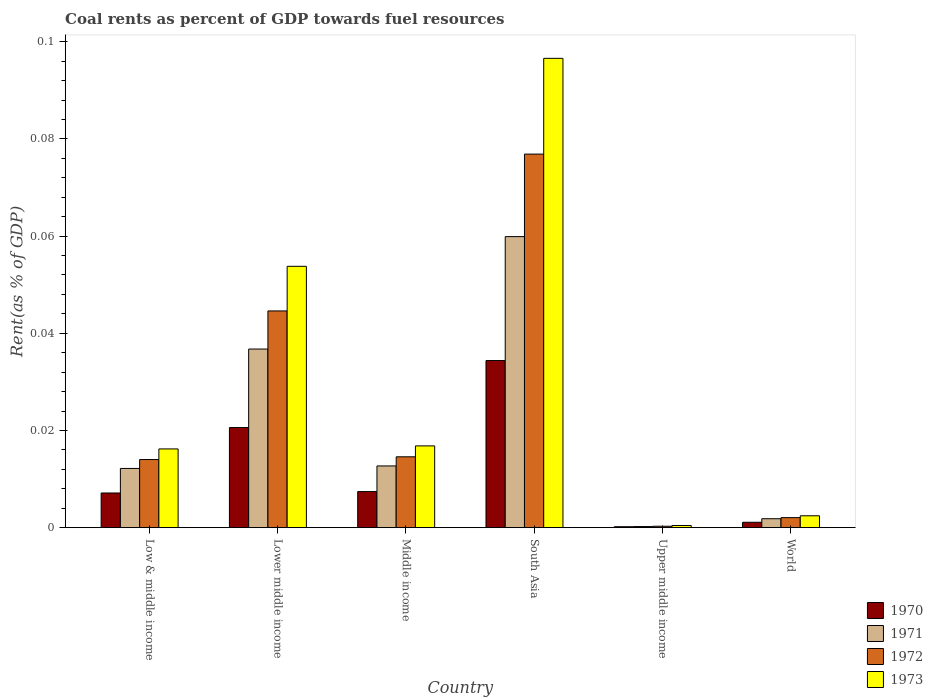How many different coloured bars are there?
Offer a very short reply. 4. How many groups of bars are there?
Provide a short and direct response. 6. How many bars are there on the 2nd tick from the left?
Your answer should be compact. 4. What is the label of the 2nd group of bars from the left?
Give a very brief answer. Lower middle income. In how many cases, is the number of bars for a given country not equal to the number of legend labels?
Provide a succinct answer. 0. What is the coal rent in 1970 in Lower middle income?
Ensure brevity in your answer.  0.02. Across all countries, what is the maximum coal rent in 1973?
Keep it short and to the point. 0.1. Across all countries, what is the minimum coal rent in 1970?
Provide a succinct answer. 0. In which country was the coal rent in 1971 minimum?
Provide a short and direct response. Upper middle income. What is the total coal rent in 1973 in the graph?
Offer a terse response. 0.19. What is the difference between the coal rent in 1971 in South Asia and that in World?
Your answer should be very brief. 0.06. What is the difference between the coal rent in 1972 in Middle income and the coal rent in 1973 in Lower middle income?
Your response must be concise. -0.04. What is the average coal rent in 1971 per country?
Your answer should be compact. 0.02. What is the difference between the coal rent of/in 1970 and coal rent of/in 1973 in Low & middle income?
Your response must be concise. -0.01. In how many countries, is the coal rent in 1970 greater than 0.04 %?
Keep it short and to the point. 0. What is the ratio of the coal rent in 1973 in Lower middle income to that in World?
Your answer should be compact. 22.07. Is the coal rent in 1973 in Middle income less than that in Upper middle income?
Offer a terse response. No. What is the difference between the highest and the second highest coal rent in 1972?
Give a very brief answer. 0.03. What is the difference between the highest and the lowest coal rent in 1972?
Ensure brevity in your answer.  0.08. In how many countries, is the coal rent in 1970 greater than the average coal rent in 1970 taken over all countries?
Give a very brief answer. 2. What does the 3rd bar from the left in Middle income represents?
Ensure brevity in your answer.  1972. What does the 3rd bar from the right in Lower middle income represents?
Make the answer very short. 1971. Is it the case that in every country, the sum of the coal rent in 1970 and coal rent in 1972 is greater than the coal rent in 1971?
Your response must be concise. Yes. Are all the bars in the graph horizontal?
Your answer should be very brief. No. How many countries are there in the graph?
Provide a succinct answer. 6. Are the values on the major ticks of Y-axis written in scientific E-notation?
Offer a terse response. No. Does the graph contain any zero values?
Provide a succinct answer. No. Does the graph contain grids?
Give a very brief answer. No. Where does the legend appear in the graph?
Provide a succinct answer. Bottom right. How are the legend labels stacked?
Give a very brief answer. Vertical. What is the title of the graph?
Make the answer very short. Coal rents as percent of GDP towards fuel resources. What is the label or title of the Y-axis?
Make the answer very short. Rent(as % of GDP). What is the Rent(as % of GDP) of 1970 in Low & middle income?
Give a very brief answer. 0.01. What is the Rent(as % of GDP) of 1971 in Low & middle income?
Give a very brief answer. 0.01. What is the Rent(as % of GDP) of 1972 in Low & middle income?
Your answer should be very brief. 0.01. What is the Rent(as % of GDP) in 1973 in Low & middle income?
Give a very brief answer. 0.02. What is the Rent(as % of GDP) in 1970 in Lower middle income?
Offer a terse response. 0.02. What is the Rent(as % of GDP) in 1971 in Lower middle income?
Your answer should be compact. 0.04. What is the Rent(as % of GDP) of 1972 in Lower middle income?
Your answer should be very brief. 0.04. What is the Rent(as % of GDP) in 1973 in Lower middle income?
Provide a succinct answer. 0.05. What is the Rent(as % of GDP) in 1970 in Middle income?
Keep it short and to the point. 0.01. What is the Rent(as % of GDP) of 1971 in Middle income?
Offer a very short reply. 0.01. What is the Rent(as % of GDP) in 1972 in Middle income?
Offer a very short reply. 0.01. What is the Rent(as % of GDP) of 1973 in Middle income?
Your answer should be compact. 0.02. What is the Rent(as % of GDP) in 1970 in South Asia?
Give a very brief answer. 0.03. What is the Rent(as % of GDP) in 1971 in South Asia?
Offer a terse response. 0.06. What is the Rent(as % of GDP) in 1972 in South Asia?
Offer a terse response. 0.08. What is the Rent(as % of GDP) of 1973 in South Asia?
Your response must be concise. 0.1. What is the Rent(as % of GDP) of 1970 in Upper middle income?
Offer a terse response. 0. What is the Rent(as % of GDP) in 1971 in Upper middle income?
Keep it short and to the point. 0. What is the Rent(as % of GDP) of 1972 in Upper middle income?
Make the answer very short. 0. What is the Rent(as % of GDP) of 1973 in Upper middle income?
Your answer should be very brief. 0. What is the Rent(as % of GDP) of 1970 in World?
Your response must be concise. 0. What is the Rent(as % of GDP) in 1971 in World?
Your response must be concise. 0. What is the Rent(as % of GDP) in 1972 in World?
Your answer should be very brief. 0. What is the Rent(as % of GDP) of 1973 in World?
Your answer should be compact. 0. Across all countries, what is the maximum Rent(as % of GDP) of 1970?
Your answer should be very brief. 0.03. Across all countries, what is the maximum Rent(as % of GDP) of 1971?
Provide a succinct answer. 0.06. Across all countries, what is the maximum Rent(as % of GDP) in 1972?
Give a very brief answer. 0.08. Across all countries, what is the maximum Rent(as % of GDP) of 1973?
Your answer should be compact. 0.1. Across all countries, what is the minimum Rent(as % of GDP) in 1970?
Your answer should be very brief. 0. Across all countries, what is the minimum Rent(as % of GDP) of 1971?
Ensure brevity in your answer.  0. Across all countries, what is the minimum Rent(as % of GDP) of 1972?
Give a very brief answer. 0. Across all countries, what is the minimum Rent(as % of GDP) of 1973?
Provide a short and direct response. 0. What is the total Rent(as % of GDP) of 1970 in the graph?
Offer a terse response. 0.07. What is the total Rent(as % of GDP) of 1971 in the graph?
Ensure brevity in your answer.  0.12. What is the total Rent(as % of GDP) of 1972 in the graph?
Your answer should be compact. 0.15. What is the total Rent(as % of GDP) of 1973 in the graph?
Offer a very short reply. 0.19. What is the difference between the Rent(as % of GDP) of 1970 in Low & middle income and that in Lower middle income?
Your answer should be very brief. -0.01. What is the difference between the Rent(as % of GDP) in 1971 in Low & middle income and that in Lower middle income?
Make the answer very short. -0.02. What is the difference between the Rent(as % of GDP) in 1972 in Low & middle income and that in Lower middle income?
Provide a succinct answer. -0.03. What is the difference between the Rent(as % of GDP) in 1973 in Low & middle income and that in Lower middle income?
Offer a terse response. -0.04. What is the difference between the Rent(as % of GDP) of 1970 in Low & middle income and that in Middle income?
Provide a succinct answer. -0. What is the difference between the Rent(as % of GDP) of 1971 in Low & middle income and that in Middle income?
Make the answer very short. -0. What is the difference between the Rent(as % of GDP) of 1972 in Low & middle income and that in Middle income?
Your answer should be very brief. -0. What is the difference between the Rent(as % of GDP) of 1973 in Low & middle income and that in Middle income?
Offer a very short reply. -0. What is the difference between the Rent(as % of GDP) of 1970 in Low & middle income and that in South Asia?
Offer a terse response. -0.03. What is the difference between the Rent(as % of GDP) in 1971 in Low & middle income and that in South Asia?
Offer a very short reply. -0.05. What is the difference between the Rent(as % of GDP) in 1972 in Low & middle income and that in South Asia?
Offer a very short reply. -0.06. What is the difference between the Rent(as % of GDP) of 1973 in Low & middle income and that in South Asia?
Ensure brevity in your answer.  -0.08. What is the difference between the Rent(as % of GDP) in 1970 in Low & middle income and that in Upper middle income?
Provide a succinct answer. 0.01. What is the difference between the Rent(as % of GDP) in 1971 in Low & middle income and that in Upper middle income?
Ensure brevity in your answer.  0.01. What is the difference between the Rent(as % of GDP) of 1972 in Low & middle income and that in Upper middle income?
Keep it short and to the point. 0.01. What is the difference between the Rent(as % of GDP) of 1973 in Low & middle income and that in Upper middle income?
Offer a very short reply. 0.02. What is the difference between the Rent(as % of GDP) in 1970 in Low & middle income and that in World?
Ensure brevity in your answer.  0.01. What is the difference between the Rent(as % of GDP) of 1971 in Low & middle income and that in World?
Give a very brief answer. 0.01. What is the difference between the Rent(as % of GDP) in 1972 in Low & middle income and that in World?
Keep it short and to the point. 0.01. What is the difference between the Rent(as % of GDP) in 1973 in Low & middle income and that in World?
Provide a short and direct response. 0.01. What is the difference between the Rent(as % of GDP) of 1970 in Lower middle income and that in Middle income?
Make the answer very short. 0.01. What is the difference between the Rent(as % of GDP) of 1971 in Lower middle income and that in Middle income?
Offer a very short reply. 0.02. What is the difference between the Rent(as % of GDP) of 1972 in Lower middle income and that in Middle income?
Keep it short and to the point. 0.03. What is the difference between the Rent(as % of GDP) in 1973 in Lower middle income and that in Middle income?
Keep it short and to the point. 0.04. What is the difference between the Rent(as % of GDP) in 1970 in Lower middle income and that in South Asia?
Make the answer very short. -0.01. What is the difference between the Rent(as % of GDP) of 1971 in Lower middle income and that in South Asia?
Provide a succinct answer. -0.02. What is the difference between the Rent(as % of GDP) of 1972 in Lower middle income and that in South Asia?
Provide a short and direct response. -0.03. What is the difference between the Rent(as % of GDP) of 1973 in Lower middle income and that in South Asia?
Give a very brief answer. -0.04. What is the difference between the Rent(as % of GDP) in 1970 in Lower middle income and that in Upper middle income?
Make the answer very short. 0.02. What is the difference between the Rent(as % of GDP) in 1971 in Lower middle income and that in Upper middle income?
Provide a succinct answer. 0.04. What is the difference between the Rent(as % of GDP) of 1972 in Lower middle income and that in Upper middle income?
Provide a succinct answer. 0.04. What is the difference between the Rent(as % of GDP) in 1973 in Lower middle income and that in Upper middle income?
Keep it short and to the point. 0.05. What is the difference between the Rent(as % of GDP) in 1970 in Lower middle income and that in World?
Your answer should be compact. 0.02. What is the difference between the Rent(as % of GDP) of 1971 in Lower middle income and that in World?
Your answer should be compact. 0.03. What is the difference between the Rent(as % of GDP) in 1972 in Lower middle income and that in World?
Provide a succinct answer. 0.04. What is the difference between the Rent(as % of GDP) in 1973 in Lower middle income and that in World?
Provide a succinct answer. 0.05. What is the difference between the Rent(as % of GDP) of 1970 in Middle income and that in South Asia?
Offer a very short reply. -0.03. What is the difference between the Rent(as % of GDP) of 1971 in Middle income and that in South Asia?
Your response must be concise. -0.05. What is the difference between the Rent(as % of GDP) of 1972 in Middle income and that in South Asia?
Your answer should be compact. -0.06. What is the difference between the Rent(as % of GDP) of 1973 in Middle income and that in South Asia?
Give a very brief answer. -0.08. What is the difference between the Rent(as % of GDP) in 1970 in Middle income and that in Upper middle income?
Provide a succinct answer. 0.01. What is the difference between the Rent(as % of GDP) in 1971 in Middle income and that in Upper middle income?
Provide a succinct answer. 0.01. What is the difference between the Rent(as % of GDP) in 1972 in Middle income and that in Upper middle income?
Your response must be concise. 0.01. What is the difference between the Rent(as % of GDP) of 1973 in Middle income and that in Upper middle income?
Your response must be concise. 0.02. What is the difference between the Rent(as % of GDP) of 1970 in Middle income and that in World?
Your answer should be very brief. 0.01. What is the difference between the Rent(as % of GDP) of 1971 in Middle income and that in World?
Provide a short and direct response. 0.01. What is the difference between the Rent(as % of GDP) of 1972 in Middle income and that in World?
Your answer should be compact. 0.01. What is the difference between the Rent(as % of GDP) of 1973 in Middle income and that in World?
Make the answer very short. 0.01. What is the difference between the Rent(as % of GDP) in 1970 in South Asia and that in Upper middle income?
Keep it short and to the point. 0.03. What is the difference between the Rent(as % of GDP) in 1971 in South Asia and that in Upper middle income?
Your response must be concise. 0.06. What is the difference between the Rent(as % of GDP) in 1972 in South Asia and that in Upper middle income?
Offer a very short reply. 0.08. What is the difference between the Rent(as % of GDP) of 1973 in South Asia and that in Upper middle income?
Offer a very short reply. 0.1. What is the difference between the Rent(as % of GDP) of 1970 in South Asia and that in World?
Ensure brevity in your answer.  0.03. What is the difference between the Rent(as % of GDP) of 1971 in South Asia and that in World?
Make the answer very short. 0.06. What is the difference between the Rent(as % of GDP) in 1972 in South Asia and that in World?
Provide a succinct answer. 0.07. What is the difference between the Rent(as % of GDP) in 1973 in South Asia and that in World?
Offer a terse response. 0.09. What is the difference between the Rent(as % of GDP) in 1970 in Upper middle income and that in World?
Your response must be concise. -0. What is the difference between the Rent(as % of GDP) of 1971 in Upper middle income and that in World?
Make the answer very short. -0. What is the difference between the Rent(as % of GDP) in 1972 in Upper middle income and that in World?
Your answer should be very brief. -0. What is the difference between the Rent(as % of GDP) of 1973 in Upper middle income and that in World?
Your answer should be compact. -0. What is the difference between the Rent(as % of GDP) in 1970 in Low & middle income and the Rent(as % of GDP) in 1971 in Lower middle income?
Provide a short and direct response. -0.03. What is the difference between the Rent(as % of GDP) of 1970 in Low & middle income and the Rent(as % of GDP) of 1972 in Lower middle income?
Your response must be concise. -0.04. What is the difference between the Rent(as % of GDP) in 1970 in Low & middle income and the Rent(as % of GDP) in 1973 in Lower middle income?
Provide a short and direct response. -0.05. What is the difference between the Rent(as % of GDP) in 1971 in Low & middle income and the Rent(as % of GDP) in 1972 in Lower middle income?
Provide a short and direct response. -0.03. What is the difference between the Rent(as % of GDP) of 1971 in Low & middle income and the Rent(as % of GDP) of 1973 in Lower middle income?
Your answer should be very brief. -0.04. What is the difference between the Rent(as % of GDP) in 1972 in Low & middle income and the Rent(as % of GDP) in 1973 in Lower middle income?
Offer a very short reply. -0.04. What is the difference between the Rent(as % of GDP) in 1970 in Low & middle income and the Rent(as % of GDP) in 1971 in Middle income?
Provide a succinct answer. -0.01. What is the difference between the Rent(as % of GDP) of 1970 in Low & middle income and the Rent(as % of GDP) of 1972 in Middle income?
Give a very brief answer. -0.01. What is the difference between the Rent(as % of GDP) of 1970 in Low & middle income and the Rent(as % of GDP) of 1973 in Middle income?
Offer a very short reply. -0.01. What is the difference between the Rent(as % of GDP) of 1971 in Low & middle income and the Rent(as % of GDP) of 1972 in Middle income?
Provide a succinct answer. -0. What is the difference between the Rent(as % of GDP) in 1971 in Low & middle income and the Rent(as % of GDP) in 1973 in Middle income?
Your answer should be very brief. -0. What is the difference between the Rent(as % of GDP) of 1972 in Low & middle income and the Rent(as % of GDP) of 1973 in Middle income?
Ensure brevity in your answer.  -0. What is the difference between the Rent(as % of GDP) in 1970 in Low & middle income and the Rent(as % of GDP) in 1971 in South Asia?
Give a very brief answer. -0.05. What is the difference between the Rent(as % of GDP) of 1970 in Low & middle income and the Rent(as % of GDP) of 1972 in South Asia?
Ensure brevity in your answer.  -0.07. What is the difference between the Rent(as % of GDP) in 1970 in Low & middle income and the Rent(as % of GDP) in 1973 in South Asia?
Keep it short and to the point. -0.09. What is the difference between the Rent(as % of GDP) in 1971 in Low & middle income and the Rent(as % of GDP) in 1972 in South Asia?
Your response must be concise. -0.06. What is the difference between the Rent(as % of GDP) in 1971 in Low & middle income and the Rent(as % of GDP) in 1973 in South Asia?
Give a very brief answer. -0.08. What is the difference between the Rent(as % of GDP) of 1972 in Low & middle income and the Rent(as % of GDP) of 1973 in South Asia?
Give a very brief answer. -0.08. What is the difference between the Rent(as % of GDP) in 1970 in Low & middle income and the Rent(as % of GDP) in 1971 in Upper middle income?
Give a very brief answer. 0.01. What is the difference between the Rent(as % of GDP) in 1970 in Low & middle income and the Rent(as % of GDP) in 1972 in Upper middle income?
Provide a short and direct response. 0.01. What is the difference between the Rent(as % of GDP) of 1970 in Low & middle income and the Rent(as % of GDP) of 1973 in Upper middle income?
Offer a very short reply. 0.01. What is the difference between the Rent(as % of GDP) in 1971 in Low & middle income and the Rent(as % of GDP) in 1972 in Upper middle income?
Your response must be concise. 0.01. What is the difference between the Rent(as % of GDP) of 1971 in Low & middle income and the Rent(as % of GDP) of 1973 in Upper middle income?
Offer a terse response. 0.01. What is the difference between the Rent(as % of GDP) in 1972 in Low & middle income and the Rent(as % of GDP) in 1973 in Upper middle income?
Provide a succinct answer. 0.01. What is the difference between the Rent(as % of GDP) in 1970 in Low & middle income and the Rent(as % of GDP) in 1971 in World?
Ensure brevity in your answer.  0.01. What is the difference between the Rent(as % of GDP) in 1970 in Low & middle income and the Rent(as % of GDP) in 1972 in World?
Keep it short and to the point. 0.01. What is the difference between the Rent(as % of GDP) of 1970 in Low & middle income and the Rent(as % of GDP) of 1973 in World?
Give a very brief answer. 0. What is the difference between the Rent(as % of GDP) of 1971 in Low & middle income and the Rent(as % of GDP) of 1972 in World?
Provide a succinct answer. 0.01. What is the difference between the Rent(as % of GDP) in 1971 in Low & middle income and the Rent(as % of GDP) in 1973 in World?
Your answer should be very brief. 0.01. What is the difference between the Rent(as % of GDP) in 1972 in Low & middle income and the Rent(as % of GDP) in 1973 in World?
Offer a terse response. 0.01. What is the difference between the Rent(as % of GDP) in 1970 in Lower middle income and the Rent(as % of GDP) in 1971 in Middle income?
Give a very brief answer. 0.01. What is the difference between the Rent(as % of GDP) of 1970 in Lower middle income and the Rent(as % of GDP) of 1972 in Middle income?
Your answer should be compact. 0.01. What is the difference between the Rent(as % of GDP) in 1970 in Lower middle income and the Rent(as % of GDP) in 1973 in Middle income?
Provide a succinct answer. 0. What is the difference between the Rent(as % of GDP) in 1971 in Lower middle income and the Rent(as % of GDP) in 1972 in Middle income?
Provide a succinct answer. 0.02. What is the difference between the Rent(as % of GDP) in 1971 in Lower middle income and the Rent(as % of GDP) in 1973 in Middle income?
Your answer should be very brief. 0.02. What is the difference between the Rent(as % of GDP) in 1972 in Lower middle income and the Rent(as % of GDP) in 1973 in Middle income?
Keep it short and to the point. 0.03. What is the difference between the Rent(as % of GDP) of 1970 in Lower middle income and the Rent(as % of GDP) of 1971 in South Asia?
Offer a terse response. -0.04. What is the difference between the Rent(as % of GDP) of 1970 in Lower middle income and the Rent(as % of GDP) of 1972 in South Asia?
Make the answer very short. -0.06. What is the difference between the Rent(as % of GDP) of 1970 in Lower middle income and the Rent(as % of GDP) of 1973 in South Asia?
Give a very brief answer. -0.08. What is the difference between the Rent(as % of GDP) of 1971 in Lower middle income and the Rent(as % of GDP) of 1972 in South Asia?
Provide a short and direct response. -0.04. What is the difference between the Rent(as % of GDP) of 1971 in Lower middle income and the Rent(as % of GDP) of 1973 in South Asia?
Offer a very short reply. -0.06. What is the difference between the Rent(as % of GDP) of 1972 in Lower middle income and the Rent(as % of GDP) of 1973 in South Asia?
Keep it short and to the point. -0.05. What is the difference between the Rent(as % of GDP) in 1970 in Lower middle income and the Rent(as % of GDP) in 1971 in Upper middle income?
Offer a terse response. 0.02. What is the difference between the Rent(as % of GDP) of 1970 in Lower middle income and the Rent(as % of GDP) of 1972 in Upper middle income?
Ensure brevity in your answer.  0.02. What is the difference between the Rent(as % of GDP) of 1970 in Lower middle income and the Rent(as % of GDP) of 1973 in Upper middle income?
Your answer should be compact. 0.02. What is the difference between the Rent(as % of GDP) in 1971 in Lower middle income and the Rent(as % of GDP) in 1972 in Upper middle income?
Make the answer very short. 0.04. What is the difference between the Rent(as % of GDP) in 1971 in Lower middle income and the Rent(as % of GDP) in 1973 in Upper middle income?
Give a very brief answer. 0.04. What is the difference between the Rent(as % of GDP) in 1972 in Lower middle income and the Rent(as % of GDP) in 1973 in Upper middle income?
Your response must be concise. 0.04. What is the difference between the Rent(as % of GDP) of 1970 in Lower middle income and the Rent(as % of GDP) of 1971 in World?
Your answer should be very brief. 0.02. What is the difference between the Rent(as % of GDP) of 1970 in Lower middle income and the Rent(as % of GDP) of 1972 in World?
Your response must be concise. 0.02. What is the difference between the Rent(as % of GDP) of 1970 in Lower middle income and the Rent(as % of GDP) of 1973 in World?
Offer a very short reply. 0.02. What is the difference between the Rent(as % of GDP) of 1971 in Lower middle income and the Rent(as % of GDP) of 1972 in World?
Offer a terse response. 0.03. What is the difference between the Rent(as % of GDP) of 1971 in Lower middle income and the Rent(as % of GDP) of 1973 in World?
Ensure brevity in your answer.  0.03. What is the difference between the Rent(as % of GDP) of 1972 in Lower middle income and the Rent(as % of GDP) of 1973 in World?
Give a very brief answer. 0.04. What is the difference between the Rent(as % of GDP) of 1970 in Middle income and the Rent(as % of GDP) of 1971 in South Asia?
Your answer should be compact. -0.05. What is the difference between the Rent(as % of GDP) of 1970 in Middle income and the Rent(as % of GDP) of 1972 in South Asia?
Offer a very short reply. -0.07. What is the difference between the Rent(as % of GDP) of 1970 in Middle income and the Rent(as % of GDP) of 1973 in South Asia?
Offer a very short reply. -0.09. What is the difference between the Rent(as % of GDP) of 1971 in Middle income and the Rent(as % of GDP) of 1972 in South Asia?
Your response must be concise. -0.06. What is the difference between the Rent(as % of GDP) of 1971 in Middle income and the Rent(as % of GDP) of 1973 in South Asia?
Offer a terse response. -0.08. What is the difference between the Rent(as % of GDP) of 1972 in Middle income and the Rent(as % of GDP) of 1973 in South Asia?
Provide a short and direct response. -0.08. What is the difference between the Rent(as % of GDP) of 1970 in Middle income and the Rent(as % of GDP) of 1971 in Upper middle income?
Offer a terse response. 0.01. What is the difference between the Rent(as % of GDP) of 1970 in Middle income and the Rent(as % of GDP) of 1972 in Upper middle income?
Provide a succinct answer. 0.01. What is the difference between the Rent(as % of GDP) of 1970 in Middle income and the Rent(as % of GDP) of 1973 in Upper middle income?
Offer a very short reply. 0.01. What is the difference between the Rent(as % of GDP) of 1971 in Middle income and the Rent(as % of GDP) of 1972 in Upper middle income?
Provide a succinct answer. 0.01. What is the difference between the Rent(as % of GDP) in 1971 in Middle income and the Rent(as % of GDP) in 1973 in Upper middle income?
Provide a short and direct response. 0.01. What is the difference between the Rent(as % of GDP) of 1972 in Middle income and the Rent(as % of GDP) of 1973 in Upper middle income?
Keep it short and to the point. 0.01. What is the difference between the Rent(as % of GDP) in 1970 in Middle income and the Rent(as % of GDP) in 1971 in World?
Provide a succinct answer. 0.01. What is the difference between the Rent(as % of GDP) in 1970 in Middle income and the Rent(as % of GDP) in 1972 in World?
Your answer should be compact. 0.01. What is the difference between the Rent(as % of GDP) in 1970 in Middle income and the Rent(as % of GDP) in 1973 in World?
Offer a very short reply. 0.01. What is the difference between the Rent(as % of GDP) of 1971 in Middle income and the Rent(as % of GDP) of 1972 in World?
Offer a very short reply. 0.01. What is the difference between the Rent(as % of GDP) in 1971 in Middle income and the Rent(as % of GDP) in 1973 in World?
Make the answer very short. 0.01. What is the difference between the Rent(as % of GDP) in 1972 in Middle income and the Rent(as % of GDP) in 1973 in World?
Keep it short and to the point. 0.01. What is the difference between the Rent(as % of GDP) of 1970 in South Asia and the Rent(as % of GDP) of 1971 in Upper middle income?
Ensure brevity in your answer.  0.03. What is the difference between the Rent(as % of GDP) of 1970 in South Asia and the Rent(as % of GDP) of 1972 in Upper middle income?
Give a very brief answer. 0.03. What is the difference between the Rent(as % of GDP) in 1970 in South Asia and the Rent(as % of GDP) in 1973 in Upper middle income?
Provide a succinct answer. 0.03. What is the difference between the Rent(as % of GDP) in 1971 in South Asia and the Rent(as % of GDP) in 1972 in Upper middle income?
Keep it short and to the point. 0.06. What is the difference between the Rent(as % of GDP) in 1971 in South Asia and the Rent(as % of GDP) in 1973 in Upper middle income?
Offer a very short reply. 0.06. What is the difference between the Rent(as % of GDP) in 1972 in South Asia and the Rent(as % of GDP) in 1973 in Upper middle income?
Your response must be concise. 0.08. What is the difference between the Rent(as % of GDP) in 1970 in South Asia and the Rent(as % of GDP) in 1971 in World?
Your answer should be compact. 0.03. What is the difference between the Rent(as % of GDP) in 1970 in South Asia and the Rent(as % of GDP) in 1972 in World?
Your answer should be compact. 0.03. What is the difference between the Rent(as % of GDP) in 1970 in South Asia and the Rent(as % of GDP) in 1973 in World?
Give a very brief answer. 0.03. What is the difference between the Rent(as % of GDP) of 1971 in South Asia and the Rent(as % of GDP) of 1972 in World?
Keep it short and to the point. 0.06. What is the difference between the Rent(as % of GDP) of 1971 in South Asia and the Rent(as % of GDP) of 1973 in World?
Keep it short and to the point. 0.06. What is the difference between the Rent(as % of GDP) of 1972 in South Asia and the Rent(as % of GDP) of 1973 in World?
Ensure brevity in your answer.  0.07. What is the difference between the Rent(as % of GDP) in 1970 in Upper middle income and the Rent(as % of GDP) in 1971 in World?
Keep it short and to the point. -0. What is the difference between the Rent(as % of GDP) of 1970 in Upper middle income and the Rent(as % of GDP) of 1972 in World?
Your answer should be very brief. -0. What is the difference between the Rent(as % of GDP) of 1970 in Upper middle income and the Rent(as % of GDP) of 1973 in World?
Offer a very short reply. -0. What is the difference between the Rent(as % of GDP) of 1971 in Upper middle income and the Rent(as % of GDP) of 1972 in World?
Keep it short and to the point. -0. What is the difference between the Rent(as % of GDP) of 1971 in Upper middle income and the Rent(as % of GDP) of 1973 in World?
Your answer should be compact. -0. What is the difference between the Rent(as % of GDP) of 1972 in Upper middle income and the Rent(as % of GDP) of 1973 in World?
Make the answer very short. -0. What is the average Rent(as % of GDP) of 1970 per country?
Provide a short and direct response. 0.01. What is the average Rent(as % of GDP) in 1971 per country?
Your answer should be compact. 0.02. What is the average Rent(as % of GDP) of 1972 per country?
Your answer should be very brief. 0.03. What is the average Rent(as % of GDP) in 1973 per country?
Offer a very short reply. 0.03. What is the difference between the Rent(as % of GDP) of 1970 and Rent(as % of GDP) of 1971 in Low & middle income?
Provide a short and direct response. -0.01. What is the difference between the Rent(as % of GDP) in 1970 and Rent(as % of GDP) in 1972 in Low & middle income?
Ensure brevity in your answer.  -0.01. What is the difference between the Rent(as % of GDP) of 1970 and Rent(as % of GDP) of 1973 in Low & middle income?
Make the answer very short. -0.01. What is the difference between the Rent(as % of GDP) in 1971 and Rent(as % of GDP) in 1972 in Low & middle income?
Your response must be concise. -0. What is the difference between the Rent(as % of GDP) of 1971 and Rent(as % of GDP) of 1973 in Low & middle income?
Your response must be concise. -0. What is the difference between the Rent(as % of GDP) in 1972 and Rent(as % of GDP) in 1973 in Low & middle income?
Your response must be concise. -0. What is the difference between the Rent(as % of GDP) of 1970 and Rent(as % of GDP) of 1971 in Lower middle income?
Make the answer very short. -0.02. What is the difference between the Rent(as % of GDP) in 1970 and Rent(as % of GDP) in 1972 in Lower middle income?
Offer a terse response. -0.02. What is the difference between the Rent(as % of GDP) in 1970 and Rent(as % of GDP) in 1973 in Lower middle income?
Keep it short and to the point. -0.03. What is the difference between the Rent(as % of GDP) of 1971 and Rent(as % of GDP) of 1972 in Lower middle income?
Ensure brevity in your answer.  -0.01. What is the difference between the Rent(as % of GDP) in 1971 and Rent(as % of GDP) in 1973 in Lower middle income?
Offer a terse response. -0.02. What is the difference between the Rent(as % of GDP) in 1972 and Rent(as % of GDP) in 1973 in Lower middle income?
Provide a short and direct response. -0.01. What is the difference between the Rent(as % of GDP) in 1970 and Rent(as % of GDP) in 1971 in Middle income?
Offer a very short reply. -0.01. What is the difference between the Rent(as % of GDP) of 1970 and Rent(as % of GDP) of 1972 in Middle income?
Provide a short and direct response. -0.01. What is the difference between the Rent(as % of GDP) in 1970 and Rent(as % of GDP) in 1973 in Middle income?
Offer a terse response. -0.01. What is the difference between the Rent(as % of GDP) of 1971 and Rent(as % of GDP) of 1972 in Middle income?
Offer a terse response. -0. What is the difference between the Rent(as % of GDP) in 1971 and Rent(as % of GDP) in 1973 in Middle income?
Offer a terse response. -0. What is the difference between the Rent(as % of GDP) of 1972 and Rent(as % of GDP) of 1973 in Middle income?
Your answer should be very brief. -0. What is the difference between the Rent(as % of GDP) of 1970 and Rent(as % of GDP) of 1971 in South Asia?
Provide a succinct answer. -0.03. What is the difference between the Rent(as % of GDP) of 1970 and Rent(as % of GDP) of 1972 in South Asia?
Make the answer very short. -0.04. What is the difference between the Rent(as % of GDP) in 1970 and Rent(as % of GDP) in 1973 in South Asia?
Your response must be concise. -0.06. What is the difference between the Rent(as % of GDP) in 1971 and Rent(as % of GDP) in 1972 in South Asia?
Give a very brief answer. -0.02. What is the difference between the Rent(as % of GDP) in 1971 and Rent(as % of GDP) in 1973 in South Asia?
Your response must be concise. -0.04. What is the difference between the Rent(as % of GDP) of 1972 and Rent(as % of GDP) of 1973 in South Asia?
Provide a succinct answer. -0.02. What is the difference between the Rent(as % of GDP) in 1970 and Rent(as % of GDP) in 1971 in Upper middle income?
Keep it short and to the point. -0. What is the difference between the Rent(as % of GDP) of 1970 and Rent(as % of GDP) of 1972 in Upper middle income?
Provide a short and direct response. -0. What is the difference between the Rent(as % of GDP) in 1970 and Rent(as % of GDP) in 1973 in Upper middle income?
Offer a very short reply. -0. What is the difference between the Rent(as % of GDP) of 1971 and Rent(as % of GDP) of 1972 in Upper middle income?
Provide a succinct answer. -0. What is the difference between the Rent(as % of GDP) in 1971 and Rent(as % of GDP) in 1973 in Upper middle income?
Your response must be concise. -0. What is the difference between the Rent(as % of GDP) in 1972 and Rent(as % of GDP) in 1973 in Upper middle income?
Provide a succinct answer. -0. What is the difference between the Rent(as % of GDP) in 1970 and Rent(as % of GDP) in 1971 in World?
Provide a short and direct response. -0. What is the difference between the Rent(as % of GDP) in 1970 and Rent(as % of GDP) in 1972 in World?
Make the answer very short. -0. What is the difference between the Rent(as % of GDP) in 1970 and Rent(as % of GDP) in 1973 in World?
Ensure brevity in your answer.  -0. What is the difference between the Rent(as % of GDP) in 1971 and Rent(as % of GDP) in 1972 in World?
Provide a succinct answer. -0. What is the difference between the Rent(as % of GDP) in 1971 and Rent(as % of GDP) in 1973 in World?
Provide a succinct answer. -0. What is the difference between the Rent(as % of GDP) of 1972 and Rent(as % of GDP) of 1973 in World?
Provide a short and direct response. -0. What is the ratio of the Rent(as % of GDP) of 1970 in Low & middle income to that in Lower middle income?
Your answer should be very brief. 0.35. What is the ratio of the Rent(as % of GDP) of 1971 in Low & middle income to that in Lower middle income?
Make the answer very short. 0.33. What is the ratio of the Rent(as % of GDP) in 1972 in Low & middle income to that in Lower middle income?
Offer a terse response. 0.31. What is the ratio of the Rent(as % of GDP) in 1973 in Low & middle income to that in Lower middle income?
Provide a succinct answer. 0.3. What is the ratio of the Rent(as % of GDP) in 1970 in Low & middle income to that in Middle income?
Offer a very short reply. 0.96. What is the ratio of the Rent(as % of GDP) of 1971 in Low & middle income to that in Middle income?
Provide a short and direct response. 0.96. What is the ratio of the Rent(as % of GDP) of 1972 in Low & middle income to that in Middle income?
Your answer should be very brief. 0.96. What is the ratio of the Rent(as % of GDP) of 1973 in Low & middle income to that in Middle income?
Provide a short and direct response. 0.96. What is the ratio of the Rent(as % of GDP) of 1970 in Low & middle income to that in South Asia?
Ensure brevity in your answer.  0.21. What is the ratio of the Rent(as % of GDP) of 1971 in Low & middle income to that in South Asia?
Offer a terse response. 0.2. What is the ratio of the Rent(as % of GDP) of 1972 in Low & middle income to that in South Asia?
Provide a short and direct response. 0.18. What is the ratio of the Rent(as % of GDP) of 1973 in Low & middle income to that in South Asia?
Offer a terse response. 0.17. What is the ratio of the Rent(as % of GDP) in 1970 in Low & middle income to that in Upper middle income?
Make the answer very short. 38.77. What is the ratio of the Rent(as % of GDP) of 1971 in Low & middle income to that in Upper middle income?
Give a very brief answer. 55.66. What is the ratio of the Rent(as % of GDP) in 1972 in Low & middle income to that in Upper middle income?
Your answer should be compact. 49.28. What is the ratio of the Rent(as % of GDP) in 1973 in Low & middle income to that in Upper middle income?
Offer a terse response. 37.59. What is the ratio of the Rent(as % of GDP) in 1970 in Low & middle income to that in World?
Offer a terse response. 6.48. What is the ratio of the Rent(as % of GDP) of 1971 in Low & middle income to that in World?
Make the answer very short. 6.65. What is the ratio of the Rent(as % of GDP) of 1972 in Low & middle income to that in World?
Give a very brief answer. 6.82. What is the ratio of the Rent(as % of GDP) in 1973 in Low & middle income to that in World?
Make the answer very short. 6.65. What is the ratio of the Rent(as % of GDP) in 1970 in Lower middle income to that in Middle income?
Make the answer very short. 2.78. What is the ratio of the Rent(as % of GDP) in 1971 in Lower middle income to that in Middle income?
Make the answer very short. 2.9. What is the ratio of the Rent(as % of GDP) in 1972 in Lower middle income to that in Middle income?
Provide a succinct answer. 3.06. What is the ratio of the Rent(as % of GDP) in 1973 in Lower middle income to that in Middle income?
Your answer should be compact. 3.2. What is the ratio of the Rent(as % of GDP) in 1970 in Lower middle income to that in South Asia?
Your answer should be compact. 0.6. What is the ratio of the Rent(as % of GDP) of 1971 in Lower middle income to that in South Asia?
Your answer should be compact. 0.61. What is the ratio of the Rent(as % of GDP) in 1972 in Lower middle income to that in South Asia?
Offer a very short reply. 0.58. What is the ratio of the Rent(as % of GDP) in 1973 in Lower middle income to that in South Asia?
Ensure brevity in your answer.  0.56. What is the ratio of the Rent(as % of GDP) of 1970 in Lower middle income to that in Upper middle income?
Keep it short and to the point. 112.03. What is the ratio of the Rent(as % of GDP) in 1971 in Lower middle income to that in Upper middle income?
Your answer should be compact. 167.98. What is the ratio of the Rent(as % of GDP) of 1972 in Lower middle income to that in Upper middle income?
Give a very brief answer. 156.82. What is the ratio of the Rent(as % of GDP) of 1973 in Lower middle income to that in Upper middle income?
Your answer should be compact. 124.82. What is the ratio of the Rent(as % of GDP) in 1970 in Lower middle income to that in World?
Give a very brief answer. 18.71. What is the ratio of the Rent(as % of GDP) in 1971 in Lower middle income to that in World?
Your answer should be very brief. 20.06. What is the ratio of the Rent(as % of GDP) of 1972 in Lower middle income to that in World?
Offer a terse response. 21.7. What is the ratio of the Rent(as % of GDP) in 1973 in Lower middle income to that in World?
Offer a terse response. 22.07. What is the ratio of the Rent(as % of GDP) in 1970 in Middle income to that in South Asia?
Ensure brevity in your answer.  0.22. What is the ratio of the Rent(as % of GDP) of 1971 in Middle income to that in South Asia?
Make the answer very short. 0.21. What is the ratio of the Rent(as % of GDP) of 1972 in Middle income to that in South Asia?
Make the answer very short. 0.19. What is the ratio of the Rent(as % of GDP) of 1973 in Middle income to that in South Asia?
Provide a short and direct response. 0.17. What is the ratio of the Rent(as % of GDP) of 1970 in Middle income to that in Upper middle income?
Make the answer very short. 40.36. What is the ratio of the Rent(as % of GDP) of 1971 in Middle income to that in Upper middle income?
Your response must be concise. 58.01. What is the ratio of the Rent(as % of GDP) in 1972 in Middle income to that in Upper middle income?
Your answer should be compact. 51.25. What is the ratio of the Rent(as % of GDP) of 1973 in Middle income to that in Upper middle income?
Your answer should be very brief. 39.04. What is the ratio of the Rent(as % of GDP) of 1970 in Middle income to that in World?
Your answer should be very brief. 6.74. What is the ratio of the Rent(as % of GDP) in 1971 in Middle income to that in World?
Your answer should be compact. 6.93. What is the ratio of the Rent(as % of GDP) in 1972 in Middle income to that in World?
Ensure brevity in your answer.  7.09. What is the ratio of the Rent(as % of GDP) of 1973 in Middle income to that in World?
Your answer should be very brief. 6.91. What is the ratio of the Rent(as % of GDP) in 1970 in South Asia to that in Upper middle income?
Your answer should be compact. 187.05. What is the ratio of the Rent(as % of GDP) in 1971 in South Asia to that in Upper middle income?
Ensure brevity in your answer.  273.74. What is the ratio of the Rent(as % of GDP) in 1972 in South Asia to that in Upper middle income?
Provide a succinct answer. 270.32. What is the ratio of the Rent(as % of GDP) of 1973 in South Asia to that in Upper middle income?
Keep it short and to the point. 224.18. What is the ratio of the Rent(as % of GDP) of 1970 in South Asia to that in World?
Give a very brief answer. 31.24. What is the ratio of the Rent(as % of GDP) in 1971 in South Asia to that in World?
Provide a succinct answer. 32.69. What is the ratio of the Rent(as % of GDP) of 1972 in South Asia to that in World?
Give a very brief answer. 37.41. What is the ratio of the Rent(as % of GDP) in 1973 in South Asia to that in World?
Keep it short and to the point. 39.65. What is the ratio of the Rent(as % of GDP) of 1970 in Upper middle income to that in World?
Ensure brevity in your answer.  0.17. What is the ratio of the Rent(as % of GDP) of 1971 in Upper middle income to that in World?
Ensure brevity in your answer.  0.12. What is the ratio of the Rent(as % of GDP) in 1972 in Upper middle income to that in World?
Ensure brevity in your answer.  0.14. What is the ratio of the Rent(as % of GDP) in 1973 in Upper middle income to that in World?
Provide a succinct answer. 0.18. What is the difference between the highest and the second highest Rent(as % of GDP) of 1970?
Keep it short and to the point. 0.01. What is the difference between the highest and the second highest Rent(as % of GDP) of 1971?
Make the answer very short. 0.02. What is the difference between the highest and the second highest Rent(as % of GDP) of 1972?
Provide a short and direct response. 0.03. What is the difference between the highest and the second highest Rent(as % of GDP) of 1973?
Offer a very short reply. 0.04. What is the difference between the highest and the lowest Rent(as % of GDP) of 1970?
Keep it short and to the point. 0.03. What is the difference between the highest and the lowest Rent(as % of GDP) in 1971?
Give a very brief answer. 0.06. What is the difference between the highest and the lowest Rent(as % of GDP) of 1972?
Make the answer very short. 0.08. What is the difference between the highest and the lowest Rent(as % of GDP) in 1973?
Offer a very short reply. 0.1. 